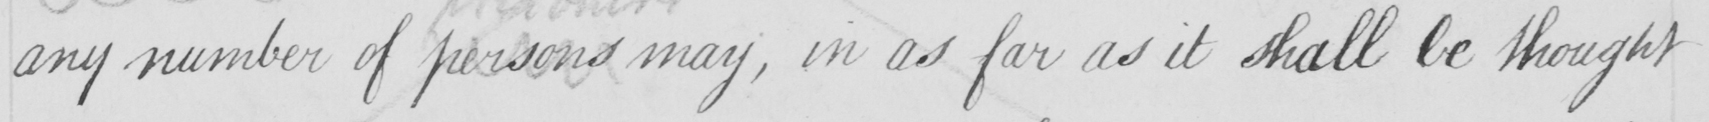Can you tell me what this handwritten text says? any number of persons may , in as far as it shall be thought 